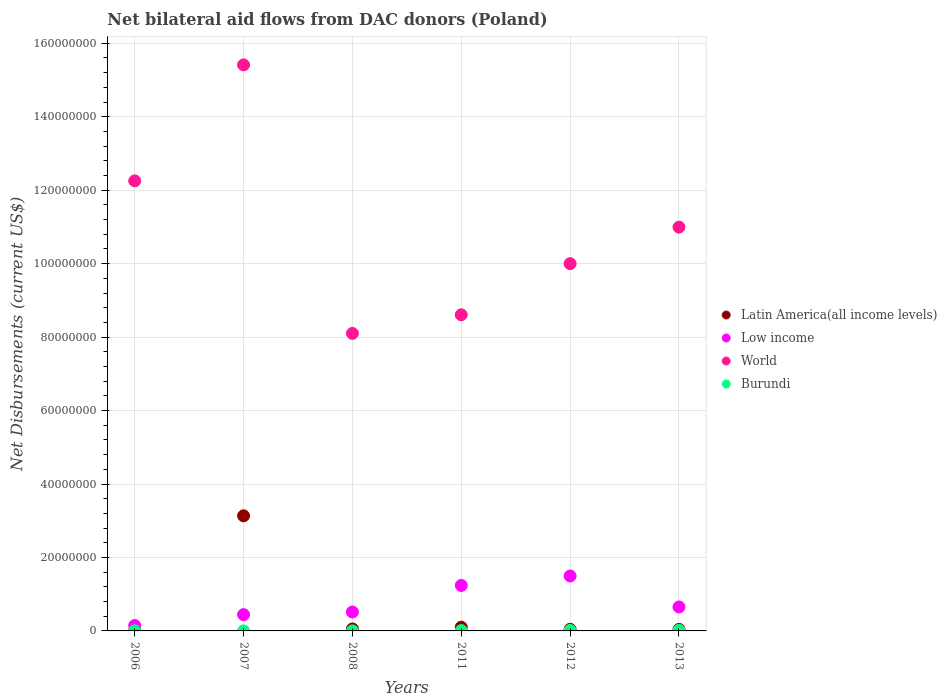Is the number of dotlines equal to the number of legend labels?
Your answer should be very brief. Yes. What is the net bilateral aid flows in World in 2007?
Your answer should be compact. 1.54e+08. Across all years, what is the maximum net bilateral aid flows in Low income?
Keep it short and to the point. 1.50e+07. Across all years, what is the minimum net bilateral aid flows in Low income?
Your answer should be compact. 1.47e+06. What is the total net bilateral aid flows in Latin America(all income levels) in the graph?
Your answer should be very brief. 3.39e+07. What is the difference between the net bilateral aid flows in Latin America(all income levels) in 2007 and that in 2013?
Your answer should be very brief. 3.09e+07. What is the difference between the net bilateral aid flows in Latin America(all income levels) in 2011 and the net bilateral aid flows in Burundi in 2013?
Your answer should be very brief. 8.50e+05. What is the average net bilateral aid flows in Latin America(all income levels) per year?
Keep it short and to the point. 5.65e+06. In the year 2012, what is the difference between the net bilateral aid flows in Burundi and net bilateral aid flows in Low income?
Keep it short and to the point. -1.48e+07. In how many years, is the net bilateral aid flows in Burundi greater than 32000000 US$?
Make the answer very short. 0. What is the ratio of the net bilateral aid flows in World in 2007 to that in 2012?
Your response must be concise. 1.54. Is the net bilateral aid flows in World in 2006 less than that in 2012?
Make the answer very short. No. Is the difference between the net bilateral aid flows in Burundi in 2008 and 2012 greater than the difference between the net bilateral aid flows in Low income in 2008 and 2012?
Offer a very short reply. Yes. What is the difference between the highest and the second highest net bilateral aid flows in Low income?
Offer a very short reply. 2.58e+06. What is the difference between the highest and the lowest net bilateral aid flows in Latin America(all income levels)?
Offer a terse response. 3.12e+07. In how many years, is the net bilateral aid flows in World greater than the average net bilateral aid flows in World taken over all years?
Provide a short and direct response. 3. Is the sum of the net bilateral aid flows in Burundi in 2008 and 2012 greater than the maximum net bilateral aid flows in Low income across all years?
Provide a short and direct response. No. Is it the case that in every year, the sum of the net bilateral aid flows in World and net bilateral aid flows in Burundi  is greater than the sum of net bilateral aid flows in Latin America(all income levels) and net bilateral aid flows in Low income?
Provide a short and direct response. Yes. Is it the case that in every year, the sum of the net bilateral aid flows in World and net bilateral aid flows in Burundi  is greater than the net bilateral aid flows in Low income?
Ensure brevity in your answer.  Yes. Is the net bilateral aid flows in Burundi strictly greater than the net bilateral aid flows in Latin America(all income levels) over the years?
Provide a short and direct response. No. Is the net bilateral aid flows in Latin America(all income levels) strictly less than the net bilateral aid flows in World over the years?
Your answer should be compact. Yes. How many dotlines are there?
Offer a terse response. 4. How many years are there in the graph?
Offer a terse response. 6. Are the values on the major ticks of Y-axis written in scientific E-notation?
Your answer should be very brief. No. Where does the legend appear in the graph?
Provide a succinct answer. Center right. How are the legend labels stacked?
Your answer should be compact. Vertical. What is the title of the graph?
Offer a very short reply. Net bilateral aid flows from DAC donors (Poland). What is the label or title of the Y-axis?
Make the answer very short. Net Disbursements (current US$). What is the Net Disbursements (current US$) in Low income in 2006?
Provide a succinct answer. 1.47e+06. What is the Net Disbursements (current US$) of World in 2006?
Ensure brevity in your answer.  1.23e+08. What is the Net Disbursements (current US$) in Burundi in 2006?
Offer a terse response. 3.00e+04. What is the Net Disbursements (current US$) of Latin America(all income levels) in 2007?
Your answer should be very brief. 3.13e+07. What is the Net Disbursements (current US$) in Low income in 2007?
Provide a succinct answer. 4.44e+06. What is the Net Disbursements (current US$) of World in 2007?
Your answer should be very brief. 1.54e+08. What is the Net Disbursements (current US$) in Low income in 2008?
Your answer should be very brief. 5.15e+06. What is the Net Disbursements (current US$) in World in 2008?
Keep it short and to the point. 8.10e+07. What is the Net Disbursements (current US$) in Burundi in 2008?
Your answer should be compact. 10000. What is the Net Disbursements (current US$) in Latin America(all income levels) in 2011?
Your answer should be very brief. 1.02e+06. What is the Net Disbursements (current US$) of Low income in 2011?
Ensure brevity in your answer.  1.24e+07. What is the Net Disbursements (current US$) in World in 2011?
Provide a short and direct response. 8.61e+07. What is the Net Disbursements (current US$) of Low income in 2012?
Ensure brevity in your answer.  1.50e+07. What is the Net Disbursements (current US$) of World in 2012?
Offer a very short reply. 1.00e+08. What is the Net Disbursements (current US$) of Burundi in 2012?
Make the answer very short. 1.40e+05. What is the Net Disbursements (current US$) of Low income in 2013?
Your response must be concise. 6.52e+06. What is the Net Disbursements (current US$) in World in 2013?
Keep it short and to the point. 1.10e+08. Across all years, what is the maximum Net Disbursements (current US$) in Latin America(all income levels)?
Give a very brief answer. 3.13e+07. Across all years, what is the maximum Net Disbursements (current US$) in Low income?
Offer a very short reply. 1.50e+07. Across all years, what is the maximum Net Disbursements (current US$) of World?
Offer a terse response. 1.54e+08. Across all years, what is the maximum Net Disbursements (current US$) in Burundi?
Your answer should be very brief. 1.70e+05. Across all years, what is the minimum Net Disbursements (current US$) of Low income?
Keep it short and to the point. 1.47e+06. Across all years, what is the minimum Net Disbursements (current US$) in World?
Provide a short and direct response. 8.10e+07. Across all years, what is the minimum Net Disbursements (current US$) of Burundi?
Give a very brief answer. 10000. What is the total Net Disbursements (current US$) of Latin America(all income levels) in the graph?
Offer a very short reply. 3.39e+07. What is the total Net Disbursements (current US$) in Low income in the graph?
Ensure brevity in your answer.  4.49e+07. What is the total Net Disbursements (current US$) of World in the graph?
Provide a short and direct response. 6.54e+08. What is the total Net Disbursements (current US$) of Burundi in the graph?
Ensure brevity in your answer.  4.50e+05. What is the difference between the Net Disbursements (current US$) of Latin America(all income levels) in 2006 and that in 2007?
Your response must be concise. -3.12e+07. What is the difference between the Net Disbursements (current US$) in Low income in 2006 and that in 2007?
Make the answer very short. -2.97e+06. What is the difference between the Net Disbursements (current US$) in World in 2006 and that in 2007?
Your answer should be compact. -3.16e+07. What is the difference between the Net Disbursements (current US$) in Burundi in 2006 and that in 2007?
Provide a succinct answer. 2.00e+04. What is the difference between the Net Disbursements (current US$) in Latin America(all income levels) in 2006 and that in 2008?
Make the answer very short. -4.00e+05. What is the difference between the Net Disbursements (current US$) in Low income in 2006 and that in 2008?
Provide a short and direct response. -3.68e+06. What is the difference between the Net Disbursements (current US$) in World in 2006 and that in 2008?
Keep it short and to the point. 4.15e+07. What is the difference between the Net Disbursements (current US$) of Burundi in 2006 and that in 2008?
Offer a very short reply. 2.00e+04. What is the difference between the Net Disbursements (current US$) in Latin America(all income levels) in 2006 and that in 2011?
Provide a short and direct response. -8.70e+05. What is the difference between the Net Disbursements (current US$) in Low income in 2006 and that in 2011?
Your answer should be compact. -1.09e+07. What is the difference between the Net Disbursements (current US$) in World in 2006 and that in 2011?
Provide a short and direct response. 3.65e+07. What is the difference between the Net Disbursements (current US$) of Burundi in 2006 and that in 2011?
Keep it short and to the point. -6.00e+04. What is the difference between the Net Disbursements (current US$) of Latin America(all income levels) in 2006 and that in 2012?
Offer a very short reply. -2.90e+05. What is the difference between the Net Disbursements (current US$) of Low income in 2006 and that in 2012?
Your answer should be compact. -1.35e+07. What is the difference between the Net Disbursements (current US$) in World in 2006 and that in 2012?
Provide a succinct answer. 2.25e+07. What is the difference between the Net Disbursements (current US$) in Burundi in 2006 and that in 2012?
Offer a terse response. -1.10e+05. What is the difference between the Net Disbursements (current US$) of Latin America(all income levels) in 2006 and that in 2013?
Provide a succinct answer. -2.70e+05. What is the difference between the Net Disbursements (current US$) of Low income in 2006 and that in 2013?
Offer a very short reply. -5.05e+06. What is the difference between the Net Disbursements (current US$) of World in 2006 and that in 2013?
Ensure brevity in your answer.  1.26e+07. What is the difference between the Net Disbursements (current US$) in Burundi in 2006 and that in 2013?
Offer a terse response. -1.40e+05. What is the difference between the Net Disbursements (current US$) of Latin America(all income levels) in 2007 and that in 2008?
Provide a succinct answer. 3.08e+07. What is the difference between the Net Disbursements (current US$) in Low income in 2007 and that in 2008?
Your response must be concise. -7.10e+05. What is the difference between the Net Disbursements (current US$) of World in 2007 and that in 2008?
Ensure brevity in your answer.  7.31e+07. What is the difference between the Net Disbursements (current US$) of Latin America(all income levels) in 2007 and that in 2011?
Your answer should be very brief. 3.03e+07. What is the difference between the Net Disbursements (current US$) of Low income in 2007 and that in 2011?
Your answer should be compact. -7.94e+06. What is the difference between the Net Disbursements (current US$) in World in 2007 and that in 2011?
Your answer should be very brief. 6.80e+07. What is the difference between the Net Disbursements (current US$) in Burundi in 2007 and that in 2011?
Offer a terse response. -8.00e+04. What is the difference between the Net Disbursements (current US$) of Latin America(all income levels) in 2007 and that in 2012?
Give a very brief answer. 3.09e+07. What is the difference between the Net Disbursements (current US$) of Low income in 2007 and that in 2012?
Ensure brevity in your answer.  -1.05e+07. What is the difference between the Net Disbursements (current US$) of World in 2007 and that in 2012?
Ensure brevity in your answer.  5.41e+07. What is the difference between the Net Disbursements (current US$) in Burundi in 2007 and that in 2012?
Offer a very short reply. -1.30e+05. What is the difference between the Net Disbursements (current US$) in Latin America(all income levels) in 2007 and that in 2013?
Your answer should be compact. 3.09e+07. What is the difference between the Net Disbursements (current US$) in Low income in 2007 and that in 2013?
Give a very brief answer. -2.08e+06. What is the difference between the Net Disbursements (current US$) in World in 2007 and that in 2013?
Provide a short and direct response. 4.42e+07. What is the difference between the Net Disbursements (current US$) of Latin America(all income levels) in 2008 and that in 2011?
Offer a terse response. -4.70e+05. What is the difference between the Net Disbursements (current US$) in Low income in 2008 and that in 2011?
Provide a succinct answer. -7.23e+06. What is the difference between the Net Disbursements (current US$) of World in 2008 and that in 2011?
Your response must be concise. -5.07e+06. What is the difference between the Net Disbursements (current US$) of Burundi in 2008 and that in 2011?
Offer a very short reply. -8.00e+04. What is the difference between the Net Disbursements (current US$) of Latin America(all income levels) in 2008 and that in 2012?
Ensure brevity in your answer.  1.10e+05. What is the difference between the Net Disbursements (current US$) in Low income in 2008 and that in 2012?
Your answer should be compact. -9.81e+06. What is the difference between the Net Disbursements (current US$) in World in 2008 and that in 2012?
Give a very brief answer. -1.90e+07. What is the difference between the Net Disbursements (current US$) of Latin America(all income levels) in 2008 and that in 2013?
Provide a succinct answer. 1.30e+05. What is the difference between the Net Disbursements (current US$) of Low income in 2008 and that in 2013?
Your answer should be very brief. -1.37e+06. What is the difference between the Net Disbursements (current US$) of World in 2008 and that in 2013?
Make the answer very short. -2.89e+07. What is the difference between the Net Disbursements (current US$) in Burundi in 2008 and that in 2013?
Keep it short and to the point. -1.60e+05. What is the difference between the Net Disbursements (current US$) of Latin America(all income levels) in 2011 and that in 2012?
Offer a very short reply. 5.80e+05. What is the difference between the Net Disbursements (current US$) of Low income in 2011 and that in 2012?
Make the answer very short. -2.58e+06. What is the difference between the Net Disbursements (current US$) of World in 2011 and that in 2012?
Your answer should be compact. -1.39e+07. What is the difference between the Net Disbursements (current US$) of Burundi in 2011 and that in 2012?
Your response must be concise. -5.00e+04. What is the difference between the Net Disbursements (current US$) of Low income in 2011 and that in 2013?
Provide a succinct answer. 5.86e+06. What is the difference between the Net Disbursements (current US$) in World in 2011 and that in 2013?
Offer a terse response. -2.39e+07. What is the difference between the Net Disbursements (current US$) of Burundi in 2011 and that in 2013?
Your answer should be very brief. -8.00e+04. What is the difference between the Net Disbursements (current US$) of Low income in 2012 and that in 2013?
Your answer should be compact. 8.44e+06. What is the difference between the Net Disbursements (current US$) in World in 2012 and that in 2013?
Provide a succinct answer. -9.94e+06. What is the difference between the Net Disbursements (current US$) in Latin America(all income levels) in 2006 and the Net Disbursements (current US$) in Low income in 2007?
Offer a very short reply. -4.29e+06. What is the difference between the Net Disbursements (current US$) in Latin America(all income levels) in 2006 and the Net Disbursements (current US$) in World in 2007?
Offer a terse response. -1.54e+08. What is the difference between the Net Disbursements (current US$) of Latin America(all income levels) in 2006 and the Net Disbursements (current US$) of Burundi in 2007?
Provide a short and direct response. 1.40e+05. What is the difference between the Net Disbursements (current US$) in Low income in 2006 and the Net Disbursements (current US$) in World in 2007?
Make the answer very short. -1.53e+08. What is the difference between the Net Disbursements (current US$) of Low income in 2006 and the Net Disbursements (current US$) of Burundi in 2007?
Your response must be concise. 1.46e+06. What is the difference between the Net Disbursements (current US$) in World in 2006 and the Net Disbursements (current US$) in Burundi in 2007?
Your answer should be compact. 1.23e+08. What is the difference between the Net Disbursements (current US$) of Latin America(all income levels) in 2006 and the Net Disbursements (current US$) of Low income in 2008?
Provide a succinct answer. -5.00e+06. What is the difference between the Net Disbursements (current US$) in Latin America(all income levels) in 2006 and the Net Disbursements (current US$) in World in 2008?
Make the answer very short. -8.08e+07. What is the difference between the Net Disbursements (current US$) in Low income in 2006 and the Net Disbursements (current US$) in World in 2008?
Make the answer very short. -7.95e+07. What is the difference between the Net Disbursements (current US$) in Low income in 2006 and the Net Disbursements (current US$) in Burundi in 2008?
Ensure brevity in your answer.  1.46e+06. What is the difference between the Net Disbursements (current US$) in World in 2006 and the Net Disbursements (current US$) in Burundi in 2008?
Your response must be concise. 1.23e+08. What is the difference between the Net Disbursements (current US$) of Latin America(all income levels) in 2006 and the Net Disbursements (current US$) of Low income in 2011?
Your answer should be compact. -1.22e+07. What is the difference between the Net Disbursements (current US$) in Latin America(all income levels) in 2006 and the Net Disbursements (current US$) in World in 2011?
Keep it short and to the point. -8.59e+07. What is the difference between the Net Disbursements (current US$) of Low income in 2006 and the Net Disbursements (current US$) of World in 2011?
Your answer should be compact. -8.46e+07. What is the difference between the Net Disbursements (current US$) in Low income in 2006 and the Net Disbursements (current US$) in Burundi in 2011?
Provide a short and direct response. 1.38e+06. What is the difference between the Net Disbursements (current US$) of World in 2006 and the Net Disbursements (current US$) of Burundi in 2011?
Offer a very short reply. 1.22e+08. What is the difference between the Net Disbursements (current US$) in Latin America(all income levels) in 2006 and the Net Disbursements (current US$) in Low income in 2012?
Ensure brevity in your answer.  -1.48e+07. What is the difference between the Net Disbursements (current US$) of Latin America(all income levels) in 2006 and the Net Disbursements (current US$) of World in 2012?
Offer a very short reply. -9.98e+07. What is the difference between the Net Disbursements (current US$) of Low income in 2006 and the Net Disbursements (current US$) of World in 2012?
Your answer should be compact. -9.85e+07. What is the difference between the Net Disbursements (current US$) in Low income in 2006 and the Net Disbursements (current US$) in Burundi in 2012?
Provide a short and direct response. 1.33e+06. What is the difference between the Net Disbursements (current US$) of World in 2006 and the Net Disbursements (current US$) of Burundi in 2012?
Make the answer very short. 1.22e+08. What is the difference between the Net Disbursements (current US$) in Latin America(all income levels) in 2006 and the Net Disbursements (current US$) in Low income in 2013?
Your response must be concise. -6.37e+06. What is the difference between the Net Disbursements (current US$) of Latin America(all income levels) in 2006 and the Net Disbursements (current US$) of World in 2013?
Your response must be concise. -1.10e+08. What is the difference between the Net Disbursements (current US$) in Latin America(all income levels) in 2006 and the Net Disbursements (current US$) in Burundi in 2013?
Ensure brevity in your answer.  -2.00e+04. What is the difference between the Net Disbursements (current US$) of Low income in 2006 and the Net Disbursements (current US$) of World in 2013?
Make the answer very short. -1.08e+08. What is the difference between the Net Disbursements (current US$) in Low income in 2006 and the Net Disbursements (current US$) in Burundi in 2013?
Offer a terse response. 1.30e+06. What is the difference between the Net Disbursements (current US$) of World in 2006 and the Net Disbursements (current US$) of Burundi in 2013?
Make the answer very short. 1.22e+08. What is the difference between the Net Disbursements (current US$) of Latin America(all income levels) in 2007 and the Net Disbursements (current US$) of Low income in 2008?
Provide a short and direct response. 2.62e+07. What is the difference between the Net Disbursements (current US$) of Latin America(all income levels) in 2007 and the Net Disbursements (current US$) of World in 2008?
Provide a short and direct response. -4.97e+07. What is the difference between the Net Disbursements (current US$) in Latin America(all income levels) in 2007 and the Net Disbursements (current US$) in Burundi in 2008?
Your answer should be very brief. 3.13e+07. What is the difference between the Net Disbursements (current US$) in Low income in 2007 and the Net Disbursements (current US$) in World in 2008?
Make the answer very short. -7.66e+07. What is the difference between the Net Disbursements (current US$) of Low income in 2007 and the Net Disbursements (current US$) of Burundi in 2008?
Your response must be concise. 4.43e+06. What is the difference between the Net Disbursements (current US$) of World in 2007 and the Net Disbursements (current US$) of Burundi in 2008?
Your answer should be very brief. 1.54e+08. What is the difference between the Net Disbursements (current US$) in Latin America(all income levels) in 2007 and the Net Disbursements (current US$) in Low income in 2011?
Ensure brevity in your answer.  1.90e+07. What is the difference between the Net Disbursements (current US$) of Latin America(all income levels) in 2007 and the Net Disbursements (current US$) of World in 2011?
Keep it short and to the point. -5.47e+07. What is the difference between the Net Disbursements (current US$) of Latin America(all income levels) in 2007 and the Net Disbursements (current US$) of Burundi in 2011?
Give a very brief answer. 3.12e+07. What is the difference between the Net Disbursements (current US$) of Low income in 2007 and the Net Disbursements (current US$) of World in 2011?
Your response must be concise. -8.16e+07. What is the difference between the Net Disbursements (current US$) in Low income in 2007 and the Net Disbursements (current US$) in Burundi in 2011?
Ensure brevity in your answer.  4.35e+06. What is the difference between the Net Disbursements (current US$) in World in 2007 and the Net Disbursements (current US$) in Burundi in 2011?
Offer a terse response. 1.54e+08. What is the difference between the Net Disbursements (current US$) of Latin America(all income levels) in 2007 and the Net Disbursements (current US$) of Low income in 2012?
Offer a very short reply. 1.64e+07. What is the difference between the Net Disbursements (current US$) in Latin America(all income levels) in 2007 and the Net Disbursements (current US$) in World in 2012?
Offer a terse response. -6.86e+07. What is the difference between the Net Disbursements (current US$) in Latin America(all income levels) in 2007 and the Net Disbursements (current US$) in Burundi in 2012?
Keep it short and to the point. 3.12e+07. What is the difference between the Net Disbursements (current US$) of Low income in 2007 and the Net Disbursements (current US$) of World in 2012?
Make the answer very short. -9.56e+07. What is the difference between the Net Disbursements (current US$) in Low income in 2007 and the Net Disbursements (current US$) in Burundi in 2012?
Provide a succinct answer. 4.30e+06. What is the difference between the Net Disbursements (current US$) of World in 2007 and the Net Disbursements (current US$) of Burundi in 2012?
Make the answer very short. 1.54e+08. What is the difference between the Net Disbursements (current US$) of Latin America(all income levels) in 2007 and the Net Disbursements (current US$) of Low income in 2013?
Your response must be concise. 2.48e+07. What is the difference between the Net Disbursements (current US$) in Latin America(all income levels) in 2007 and the Net Disbursements (current US$) in World in 2013?
Make the answer very short. -7.86e+07. What is the difference between the Net Disbursements (current US$) in Latin America(all income levels) in 2007 and the Net Disbursements (current US$) in Burundi in 2013?
Make the answer very short. 3.12e+07. What is the difference between the Net Disbursements (current US$) in Low income in 2007 and the Net Disbursements (current US$) in World in 2013?
Your answer should be compact. -1.05e+08. What is the difference between the Net Disbursements (current US$) in Low income in 2007 and the Net Disbursements (current US$) in Burundi in 2013?
Your response must be concise. 4.27e+06. What is the difference between the Net Disbursements (current US$) in World in 2007 and the Net Disbursements (current US$) in Burundi in 2013?
Offer a very short reply. 1.54e+08. What is the difference between the Net Disbursements (current US$) in Latin America(all income levels) in 2008 and the Net Disbursements (current US$) in Low income in 2011?
Make the answer very short. -1.18e+07. What is the difference between the Net Disbursements (current US$) of Latin America(all income levels) in 2008 and the Net Disbursements (current US$) of World in 2011?
Keep it short and to the point. -8.55e+07. What is the difference between the Net Disbursements (current US$) of Low income in 2008 and the Net Disbursements (current US$) of World in 2011?
Make the answer very short. -8.09e+07. What is the difference between the Net Disbursements (current US$) in Low income in 2008 and the Net Disbursements (current US$) in Burundi in 2011?
Offer a terse response. 5.06e+06. What is the difference between the Net Disbursements (current US$) in World in 2008 and the Net Disbursements (current US$) in Burundi in 2011?
Give a very brief answer. 8.09e+07. What is the difference between the Net Disbursements (current US$) in Latin America(all income levels) in 2008 and the Net Disbursements (current US$) in Low income in 2012?
Offer a very short reply. -1.44e+07. What is the difference between the Net Disbursements (current US$) in Latin America(all income levels) in 2008 and the Net Disbursements (current US$) in World in 2012?
Ensure brevity in your answer.  -9.94e+07. What is the difference between the Net Disbursements (current US$) in Low income in 2008 and the Net Disbursements (current US$) in World in 2012?
Offer a very short reply. -9.48e+07. What is the difference between the Net Disbursements (current US$) in Low income in 2008 and the Net Disbursements (current US$) in Burundi in 2012?
Give a very brief answer. 5.01e+06. What is the difference between the Net Disbursements (current US$) in World in 2008 and the Net Disbursements (current US$) in Burundi in 2012?
Ensure brevity in your answer.  8.09e+07. What is the difference between the Net Disbursements (current US$) of Latin America(all income levels) in 2008 and the Net Disbursements (current US$) of Low income in 2013?
Provide a short and direct response. -5.97e+06. What is the difference between the Net Disbursements (current US$) in Latin America(all income levels) in 2008 and the Net Disbursements (current US$) in World in 2013?
Give a very brief answer. -1.09e+08. What is the difference between the Net Disbursements (current US$) of Low income in 2008 and the Net Disbursements (current US$) of World in 2013?
Offer a very short reply. -1.05e+08. What is the difference between the Net Disbursements (current US$) of Low income in 2008 and the Net Disbursements (current US$) of Burundi in 2013?
Offer a terse response. 4.98e+06. What is the difference between the Net Disbursements (current US$) in World in 2008 and the Net Disbursements (current US$) in Burundi in 2013?
Your answer should be compact. 8.08e+07. What is the difference between the Net Disbursements (current US$) in Latin America(all income levels) in 2011 and the Net Disbursements (current US$) in Low income in 2012?
Your answer should be very brief. -1.39e+07. What is the difference between the Net Disbursements (current US$) in Latin America(all income levels) in 2011 and the Net Disbursements (current US$) in World in 2012?
Your answer should be very brief. -9.90e+07. What is the difference between the Net Disbursements (current US$) in Latin America(all income levels) in 2011 and the Net Disbursements (current US$) in Burundi in 2012?
Your answer should be compact. 8.80e+05. What is the difference between the Net Disbursements (current US$) in Low income in 2011 and the Net Disbursements (current US$) in World in 2012?
Provide a succinct answer. -8.76e+07. What is the difference between the Net Disbursements (current US$) in Low income in 2011 and the Net Disbursements (current US$) in Burundi in 2012?
Give a very brief answer. 1.22e+07. What is the difference between the Net Disbursements (current US$) of World in 2011 and the Net Disbursements (current US$) of Burundi in 2012?
Your response must be concise. 8.59e+07. What is the difference between the Net Disbursements (current US$) of Latin America(all income levels) in 2011 and the Net Disbursements (current US$) of Low income in 2013?
Your response must be concise. -5.50e+06. What is the difference between the Net Disbursements (current US$) of Latin America(all income levels) in 2011 and the Net Disbursements (current US$) of World in 2013?
Ensure brevity in your answer.  -1.09e+08. What is the difference between the Net Disbursements (current US$) of Latin America(all income levels) in 2011 and the Net Disbursements (current US$) of Burundi in 2013?
Offer a very short reply. 8.50e+05. What is the difference between the Net Disbursements (current US$) of Low income in 2011 and the Net Disbursements (current US$) of World in 2013?
Offer a terse response. -9.76e+07. What is the difference between the Net Disbursements (current US$) of Low income in 2011 and the Net Disbursements (current US$) of Burundi in 2013?
Your answer should be compact. 1.22e+07. What is the difference between the Net Disbursements (current US$) in World in 2011 and the Net Disbursements (current US$) in Burundi in 2013?
Offer a terse response. 8.59e+07. What is the difference between the Net Disbursements (current US$) in Latin America(all income levels) in 2012 and the Net Disbursements (current US$) in Low income in 2013?
Provide a succinct answer. -6.08e+06. What is the difference between the Net Disbursements (current US$) of Latin America(all income levels) in 2012 and the Net Disbursements (current US$) of World in 2013?
Provide a short and direct response. -1.09e+08. What is the difference between the Net Disbursements (current US$) in Latin America(all income levels) in 2012 and the Net Disbursements (current US$) in Burundi in 2013?
Your answer should be compact. 2.70e+05. What is the difference between the Net Disbursements (current US$) in Low income in 2012 and the Net Disbursements (current US$) in World in 2013?
Offer a very short reply. -9.50e+07. What is the difference between the Net Disbursements (current US$) in Low income in 2012 and the Net Disbursements (current US$) in Burundi in 2013?
Offer a terse response. 1.48e+07. What is the difference between the Net Disbursements (current US$) in World in 2012 and the Net Disbursements (current US$) in Burundi in 2013?
Offer a terse response. 9.98e+07. What is the average Net Disbursements (current US$) in Latin America(all income levels) per year?
Ensure brevity in your answer.  5.65e+06. What is the average Net Disbursements (current US$) of Low income per year?
Your answer should be compact. 7.49e+06. What is the average Net Disbursements (current US$) of World per year?
Offer a very short reply. 1.09e+08. What is the average Net Disbursements (current US$) of Burundi per year?
Your response must be concise. 7.50e+04. In the year 2006, what is the difference between the Net Disbursements (current US$) of Latin America(all income levels) and Net Disbursements (current US$) of Low income?
Give a very brief answer. -1.32e+06. In the year 2006, what is the difference between the Net Disbursements (current US$) of Latin America(all income levels) and Net Disbursements (current US$) of World?
Provide a short and direct response. -1.22e+08. In the year 2006, what is the difference between the Net Disbursements (current US$) in Latin America(all income levels) and Net Disbursements (current US$) in Burundi?
Offer a terse response. 1.20e+05. In the year 2006, what is the difference between the Net Disbursements (current US$) in Low income and Net Disbursements (current US$) in World?
Ensure brevity in your answer.  -1.21e+08. In the year 2006, what is the difference between the Net Disbursements (current US$) in Low income and Net Disbursements (current US$) in Burundi?
Offer a terse response. 1.44e+06. In the year 2006, what is the difference between the Net Disbursements (current US$) in World and Net Disbursements (current US$) in Burundi?
Provide a succinct answer. 1.22e+08. In the year 2007, what is the difference between the Net Disbursements (current US$) in Latin America(all income levels) and Net Disbursements (current US$) in Low income?
Your answer should be compact. 2.69e+07. In the year 2007, what is the difference between the Net Disbursements (current US$) in Latin America(all income levels) and Net Disbursements (current US$) in World?
Keep it short and to the point. -1.23e+08. In the year 2007, what is the difference between the Net Disbursements (current US$) of Latin America(all income levels) and Net Disbursements (current US$) of Burundi?
Your answer should be compact. 3.13e+07. In the year 2007, what is the difference between the Net Disbursements (current US$) in Low income and Net Disbursements (current US$) in World?
Give a very brief answer. -1.50e+08. In the year 2007, what is the difference between the Net Disbursements (current US$) in Low income and Net Disbursements (current US$) in Burundi?
Offer a very short reply. 4.43e+06. In the year 2007, what is the difference between the Net Disbursements (current US$) in World and Net Disbursements (current US$) in Burundi?
Your answer should be very brief. 1.54e+08. In the year 2008, what is the difference between the Net Disbursements (current US$) of Latin America(all income levels) and Net Disbursements (current US$) of Low income?
Your answer should be very brief. -4.60e+06. In the year 2008, what is the difference between the Net Disbursements (current US$) of Latin America(all income levels) and Net Disbursements (current US$) of World?
Your answer should be compact. -8.04e+07. In the year 2008, what is the difference between the Net Disbursements (current US$) in Latin America(all income levels) and Net Disbursements (current US$) in Burundi?
Provide a succinct answer. 5.40e+05. In the year 2008, what is the difference between the Net Disbursements (current US$) of Low income and Net Disbursements (current US$) of World?
Your response must be concise. -7.58e+07. In the year 2008, what is the difference between the Net Disbursements (current US$) in Low income and Net Disbursements (current US$) in Burundi?
Make the answer very short. 5.14e+06. In the year 2008, what is the difference between the Net Disbursements (current US$) of World and Net Disbursements (current US$) of Burundi?
Keep it short and to the point. 8.10e+07. In the year 2011, what is the difference between the Net Disbursements (current US$) of Latin America(all income levels) and Net Disbursements (current US$) of Low income?
Give a very brief answer. -1.14e+07. In the year 2011, what is the difference between the Net Disbursements (current US$) of Latin America(all income levels) and Net Disbursements (current US$) of World?
Provide a short and direct response. -8.50e+07. In the year 2011, what is the difference between the Net Disbursements (current US$) in Latin America(all income levels) and Net Disbursements (current US$) in Burundi?
Your response must be concise. 9.30e+05. In the year 2011, what is the difference between the Net Disbursements (current US$) in Low income and Net Disbursements (current US$) in World?
Make the answer very short. -7.37e+07. In the year 2011, what is the difference between the Net Disbursements (current US$) in Low income and Net Disbursements (current US$) in Burundi?
Offer a very short reply. 1.23e+07. In the year 2011, what is the difference between the Net Disbursements (current US$) of World and Net Disbursements (current US$) of Burundi?
Provide a succinct answer. 8.60e+07. In the year 2012, what is the difference between the Net Disbursements (current US$) in Latin America(all income levels) and Net Disbursements (current US$) in Low income?
Ensure brevity in your answer.  -1.45e+07. In the year 2012, what is the difference between the Net Disbursements (current US$) in Latin America(all income levels) and Net Disbursements (current US$) in World?
Keep it short and to the point. -9.96e+07. In the year 2012, what is the difference between the Net Disbursements (current US$) in Low income and Net Disbursements (current US$) in World?
Give a very brief answer. -8.50e+07. In the year 2012, what is the difference between the Net Disbursements (current US$) of Low income and Net Disbursements (current US$) of Burundi?
Provide a succinct answer. 1.48e+07. In the year 2012, what is the difference between the Net Disbursements (current US$) in World and Net Disbursements (current US$) in Burundi?
Offer a terse response. 9.98e+07. In the year 2013, what is the difference between the Net Disbursements (current US$) of Latin America(all income levels) and Net Disbursements (current US$) of Low income?
Provide a short and direct response. -6.10e+06. In the year 2013, what is the difference between the Net Disbursements (current US$) in Latin America(all income levels) and Net Disbursements (current US$) in World?
Provide a short and direct response. -1.10e+08. In the year 2013, what is the difference between the Net Disbursements (current US$) of Low income and Net Disbursements (current US$) of World?
Your response must be concise. -1.03e+08. In the year 2013, what is the difference between the Net Disbursements (current US$) of Low income and Net Disbursements (current US$) of Burundi?
Ensure brevity in your answer.  6.35e+06. In the year 2013, what is the difference between the Net Disbursements (current US$) in World and Net Disbursements (current US$) in Burundi?
Keep it short and to the point. 1.10e+08. What is the ratio of the Net Disbursements (current US$) in Latin America(all income levels) in 2006 to that in 2007?
Ensure brevity in your answer.  0. What is the ratio of the Net Disbursements (current US$) of Low income in 2006 to that in 2007?
Your answer should be compact. 0.33. What is the ratio of the Net Disbursements (current US$) of World in 2006 to that in 2007?
Your answer should be compact. 0.8. What is the ratio of the Net Disbursements (current US$) in Burundi in 2006 to that in 2007?
Keep it short and to the point. 3. What is the ratio of the Net Disbursements (current US$) in Latin America(all income levels) in 2006 to that in 2008?
Ensure brevity in your answer.  0.27. What is the ratio of the Net Disbursements (current US$) of Low income in 2006 to that in 2008?
Offer a very short reply. 0.29. What is the ratio of the Net Disbursements (current US$) in World in 2006 to that in 2008?
Provide a succinct answer. 1.51. What is the ratio of the Net Disbursements (current US$) in Latin America(all income levels) in 2006 to that in 2011?
Keep it short and to the point. 0.15. What is the ratio of the Net Disbursements (current US$) in Low income in 2006 to that in 2011?
Your answer should be very brief. 0.12. What is the ratio of the Net Disbursements (current US$) in World in 2006 to that in 2011?
Provide a succinct answer. 1.42. What is the ratio of the Net Disbursements (current US$) of Burundi in 2006 to that in 2011?
Keep it short and to the point. 0.33. What is the ratio of the Net Disbursements (current US$) in Latin America(all income levels) in 2006 to that in 2012?
Offer a terse response. 0.34. What is the ratio of the Net Disbursements (current US$) in Low income in 2006 to that in 2012?
Provide a succinct answer. 0.1. What is the ratio of the Net Disbursements (current US$) of World in 2006 to that in 2012?
Your response must be concise. 1.23. What is the ratio of the Net Disbursements (current US$) of Burundi in 2006 to that in 2012?
Offer a terse response. 0.21. What is the ratio of the Net Disbursements (current US$) of Latin America(all income levels) in 2006 to that in 2013?
Your answer should be compact. 0.36. What is the ratio of the Net Disbursements (current US$) of Low income in 2006 to that in 2013?
Offer a very short reply. 0.23. What is the ratio of the Net Disbursements (current US$) in World in 2006 to that in 2013?
Make the answer very short. 1.11. What is the ratio of the Net Disbursements (current US$) of Burundi in 2006 to that in 2013?
Make the answer very short. 0.18. What is the ratio of the Net Disbursements (current US$) of Latin America(all income levels) in 2007 to that in 2008?
Your answer should be compact. 56.98. What is the ratio of the Net Disbursements (current US$) of Low income in 2007 to that in 2008?
Make the answer very short. 0.86. What is the ratio of the Net Disbursements (current US$) in World in 2007 to that in 2008?
Your response must be concise. 1.9. What is the ratio of the Net Disbursements (current US$) in Latin America(all income levels) in 2007 to that in 2011?
Give a very brief answer. 30.73. What is the ratio of the Net Disbursements (current US$) of Low income in 2007 to that in 2011?
Give a very brief answer. 0.36. What is the ratio of the Net Disbursements (current US$) of World in 2007 to that in 2011?
Your answer should be compact. 1.79. What is the ratio of the Net Disbursements (current US$) of Burundi in 2007 to that in 2011?
Make the answer very short. 0.11. What is the ratio of the Net Disbursements (current US$) in Latin America(all income levels) in 2007 to that in 2012?
Provide a succinct answer. 71.23. What is the ratio of the Net Disbursements (current US$) in Low income in 2007 to that in 2012?
Make the answer very short. 0.3. What is the ratio of the Net Disbursements (current US$) in World in 2007 to that in 2012?
Offer a very short reply. 1.54. What is the ratio of the Net Disbursements (current US$) of Burundi in 2007 to that in 2012?
Provide a succinct answer. 0.07. What is the ratio of the Net Disbursements (current US$) of Latin America(all income levels) in 2007 to that in 2013?
Provide a succinct answer. 74.62. What is the ratio of the Net Disbursements (current US$) of Low income in 2007 to that in 2013?
Your answer should be very brief. 0.68. What is the ratio of the Net Disbursements (current US$) in World in 2007 to that in 2013?
Make the answer very short. 1.4. What is the ratio of the Net Disbursements (current US$) in Burundi in 2007 to that in 2013?
Your answer should be very brief. 0.06. What is the ratio of the Net Disbursements (current US$) of Latin America(all income levels) in 2008 to that in 2011?
Provide a succinct answer. 0.54. What is the ratio of the Net Disbursements (current US$) of Low income in 2008 to that in 2011?
Your response must be concise. 0.42. What is the ratio of the Net Disbursements (current US$) of World in 2008 to that in 2011?
Ensure brevity in your answer.  0.94. What is the ratio of the Net Disbursements (current US$) in Latin America(all income levels) in 2008 to that in 2012?
Your response must be concise. 1.25. What is the ratio of the Net Disbursements (current US$) in Low income in 2008 to that in 2012?
Keep it short and to the point. 0.34. What is the ratio of the Net Disbursements (current US$) of World in 2008 to that in 2012?
Ensure brevity in your answer.  0.81. What is the ratio of the Net Disbursements (current US$) in Burundi in 2008 to that in 2012?
Give a very brief answer. 0.07. What is the ratio of the Net Disbursements (current US$) of Latin America(all income levels) in 2008 to that in 2013?
Keep it short and to the point. 1.31. What is the ratio of the Net Disbursements (current US$) of Low income in 2008 to that in 2013?
Offer a terse response. 0.79. What is the ratio of the Net Disbursements (current US$) in World in 2008 to that in 2013?
Your response must be concise. 0.74. What is the ratio of the Net Disbursements (current US$) of Burundi in 2008 to that in 2013?
Offer a terse response. 0.06. What is the ratio of the Net Disbursements (current US$) in Latin America(all income levels) in 2011 to that in 2012?
Keep it short and to the point. 2.32. What is the ratio of the Net Disbursements (current US$) of Low income in 2011 to that in 2012?
Your response must be concise. 0.83. What is the ratio of the Net Disbursements (current US$) in World in 2011 to that in 2012?
Ensure brevity in your answer.  0.86. What is the ratio of the Net Disbursements (current US$) of Burundi in 2011 to that in 2012?
Offer a very short reply. 0.64. What is the ratio of the Net Disbursements (current US$) of Latin America(all income levels) in 2011 to that in 2013?
Keep it short and to the point. 2.43. What is the ratio of the Net Disbursements (current US$) in Low income in 2011 to that in 2013?
Make the answer very short. 1.9. What is the ratio of the Net Disbursements (current US$) in World in 2011 to that in 2013?
Provide a succinct answer. 0.78. What is the ratio of the Net Disbursements (current US$) in Burundi in 2011 to that in 2013?
Your answer should be very brief. 0.53. What is the ratio of the Net Disbursements (current US$) in Latin America(all income levels) in 2012 to that in 2013?
Ensure brevity in your answer.  1.05. What is the ratio of the Net Disbursements (current US$) of Low income in 2012 to that in 2013?
Provide a short and direct response. 2.29. What is the ratio of the Net Disbursements (current US$) in World in 2012 to that in 2013?
Provide a short and direct response. 0.91. What is the ratio of the Net Disbursements (current US$) in Burundi in 2012 to that in 2013?
Provide a short and direct response. 0.82. What is the difference between the highest and the second highest Net Disbursements (current US$) of Latin America(all income levels)?
Keep it short and to the point. 3.03e+07. What is the difference between the highest and the second highest Net Disbursements (current US$) in Low income?
Your response must be concise. 2.58e+06. What is the difference between the highest and the second highest Net Disbursements (current US$) of World?
Provide a short and direct response. 3.16e+07. What is the difference between the highest and the second highest Net Disbursements (current US$) in Burundi?
Your answer should be compact. 3.00e+04. What is the difference between the highest and the lowest Net Disbursements (current US$) of Latin America(all income levels)?
Offer a very short reply. 3.12e+07. What is the difference between the highest and the lowest Net Disbursements (current US$) in Low income?
Provide a short and direct response. 1.35e+07. What is the difference between the highest and the lowest Net Disbursements (current US$) in World?
Give a very brief answer. 7.31e+07. What is the difference between the highest and the lowest Net Disbursements (current US$) in Burundi?
Offer a very short reply. 1.60e+05. 